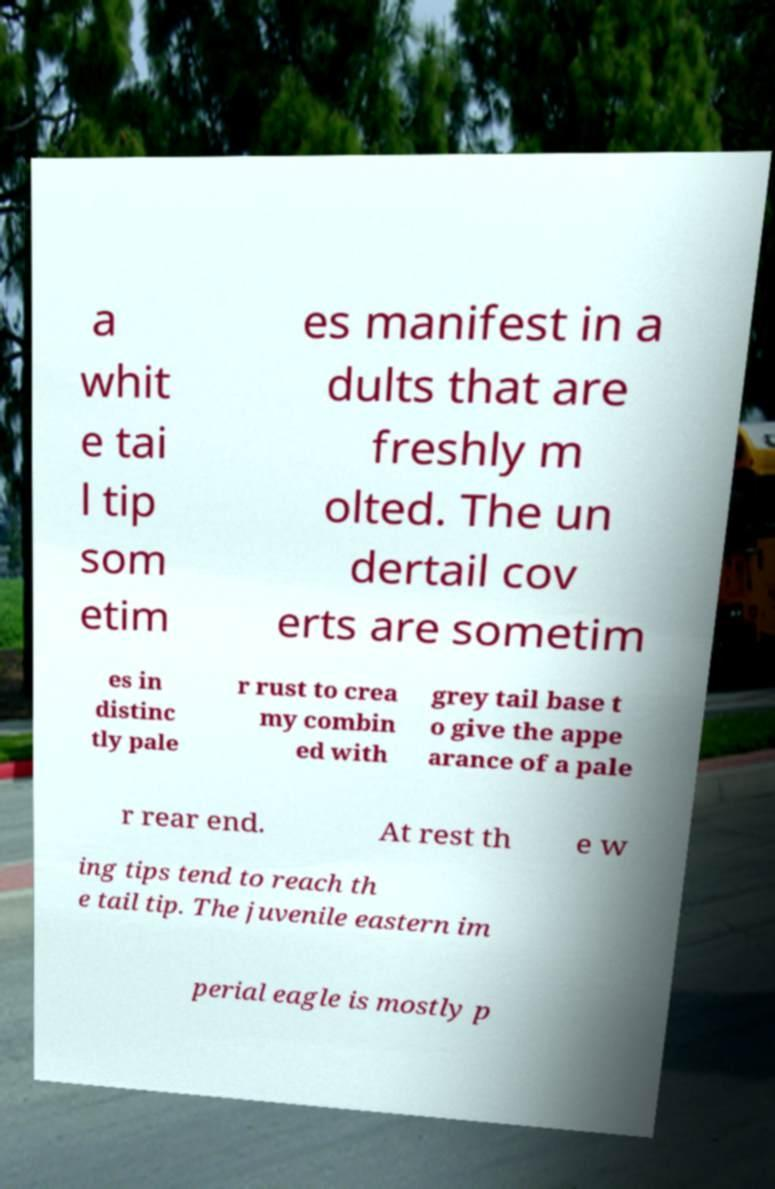There's text embedded in this image that I need extracted. Can you transcribe it verbatim? a whit e tai l tip som etim es manifest in a dults that are freshly m olted. The un dertail cov erts are sometim es in distinc tly pale r rust to crea my combin ed with grey tail base t o give the appe arance of a pale r rear end. At rest th e w ing tips tend to reach th e tail tip. The juvenile eastern im perial eagle is mostly p 